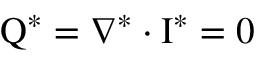<formula> <loc_0><loc_0><loc_500><loc_500>Q ^ { * } = \nabla ^ { * } \cdot I ^ { * } = 0</formula> 